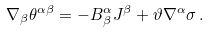Convert formula to latex. <formula><loc_0><loc_0><loc_500><loc_500>\nabla _ { \beta } \theta ^ { \alpha \beta } = - B ^ { \alpha } _ { \beta } J ^ { \beta } + \vartheta \nabla ^ { \alpha } \sigma \, .</formula> 